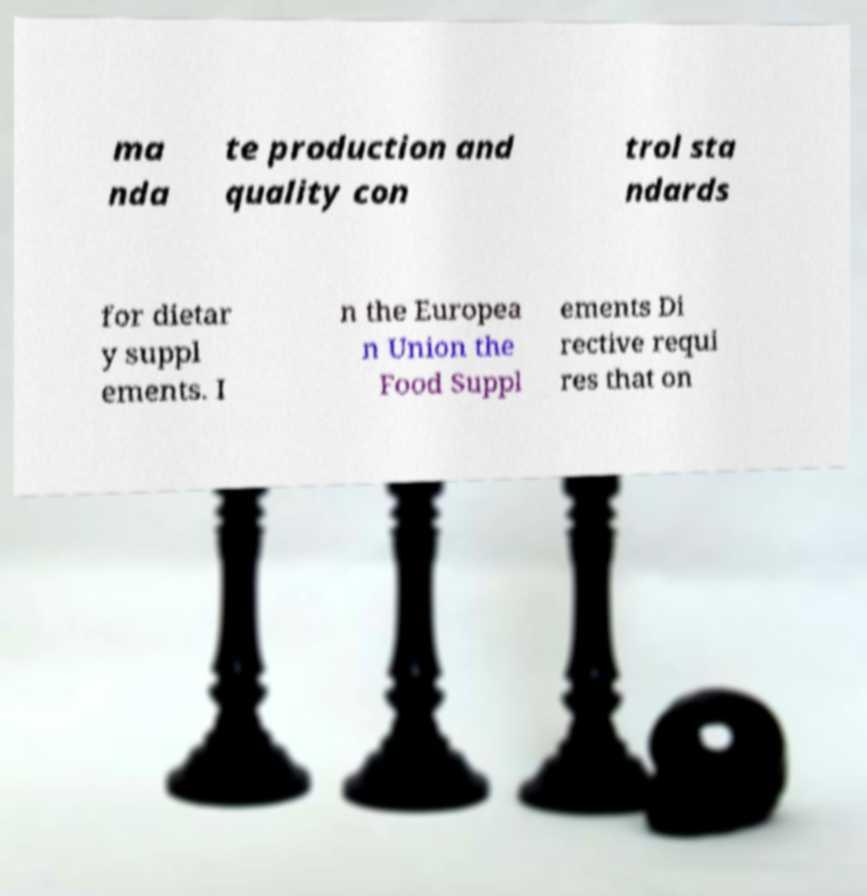Can you read and provide the text displayed in the image?This photo seems to have some interesting text. Can you extract and type it out for me? ma nda te production and quality con trol sta ndards for dietar y suppl ements. I n the Europea n Union the Food Suppl ements Di rective requi res that on 